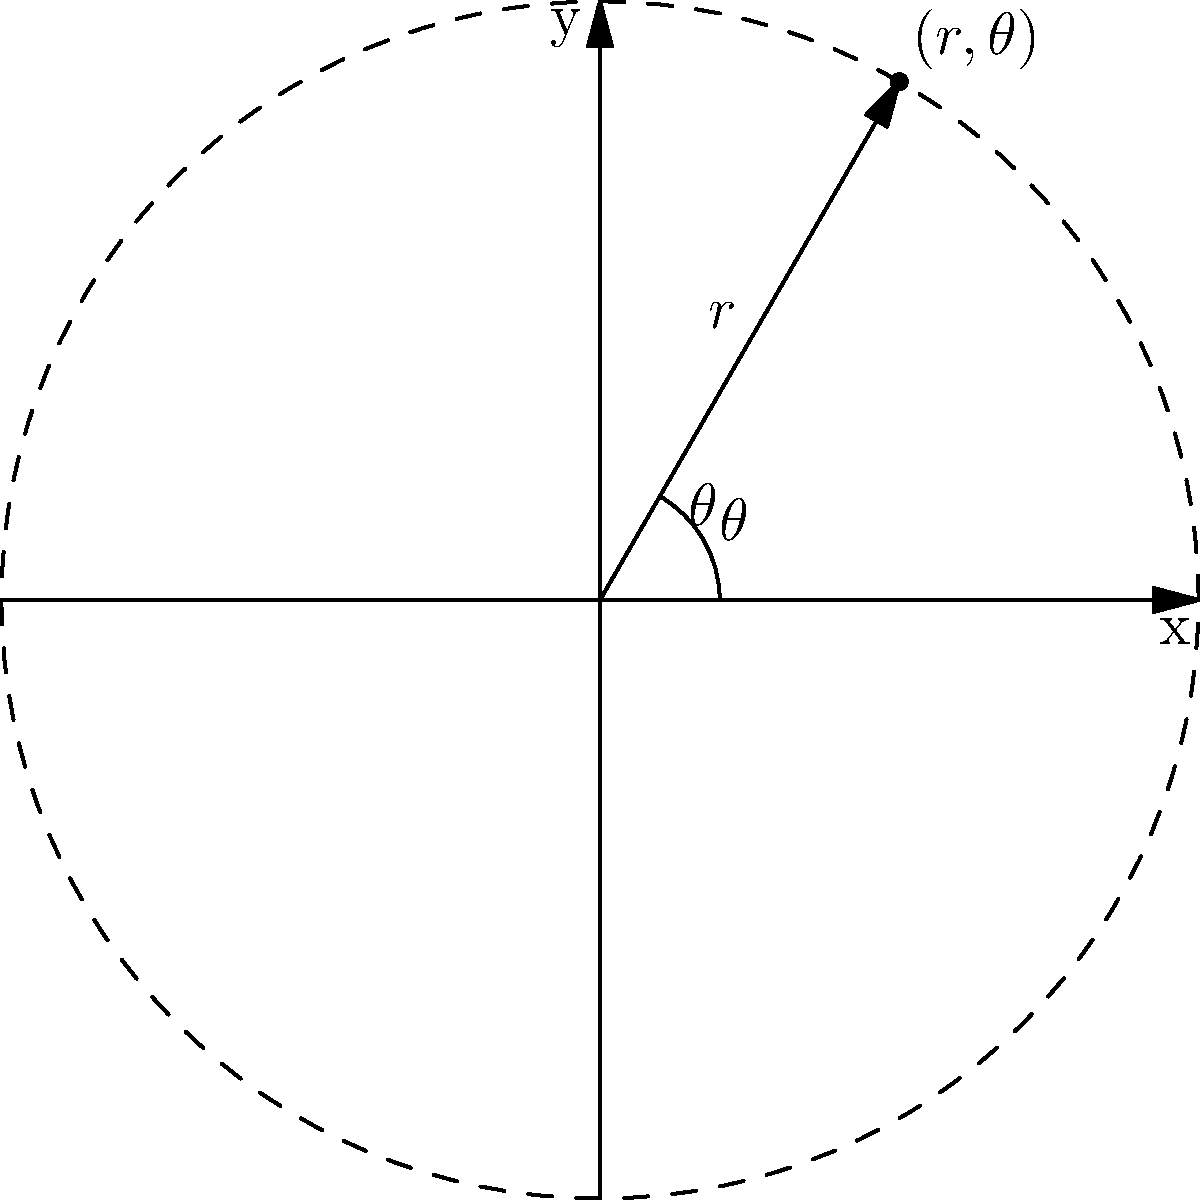As an IT Support Specialist, you're tasked with mapping network infrastructure using a polar coordinate system. Given a network node at polar coordinates $(5, \frac{\pi}{3})$, what are its Cartesian coordinates $(x, y)$ for placement on a standard grid? Round your answer to two decimal places. Let's approach this step-by-step:

1. Recall the formulas for converting polar coordinates $(r, \theta)$ to Cartesian coordinates $(x, y)$:
   $x = r \cos(\theta)$
   $y = r \sin(\theta)$

2. We're given:
   $r = 5$
   $\theta = \frac{\pi}{3}$

3. Let's calculate $x$:
   $x = r \cos(\theta) = 5 \cos(\frac{\pi}{3})$
   $\cos(\frac{\pi}{3}) = 0.5$
   $x = 5 * 0.5 = 2.5$

4. Now, let's calculate $y$:
   $y = r \sin(\theta) = 5 \sin(\frac{\pi}{3})$
   $\sin(\frac{\pi}{3}) = \frac{\sqrt{3}}{2} \approx 0.866$
   $y = 5 * 0.866 = 4.33$

5. Rounding both values to two decimal places:
   $x \approx 2.50$
   $y \approx 4.33$

Therefore, the Cartesian coordinates are approximately (2.50, 4.33).
Answer: (2.50, 4.33) 